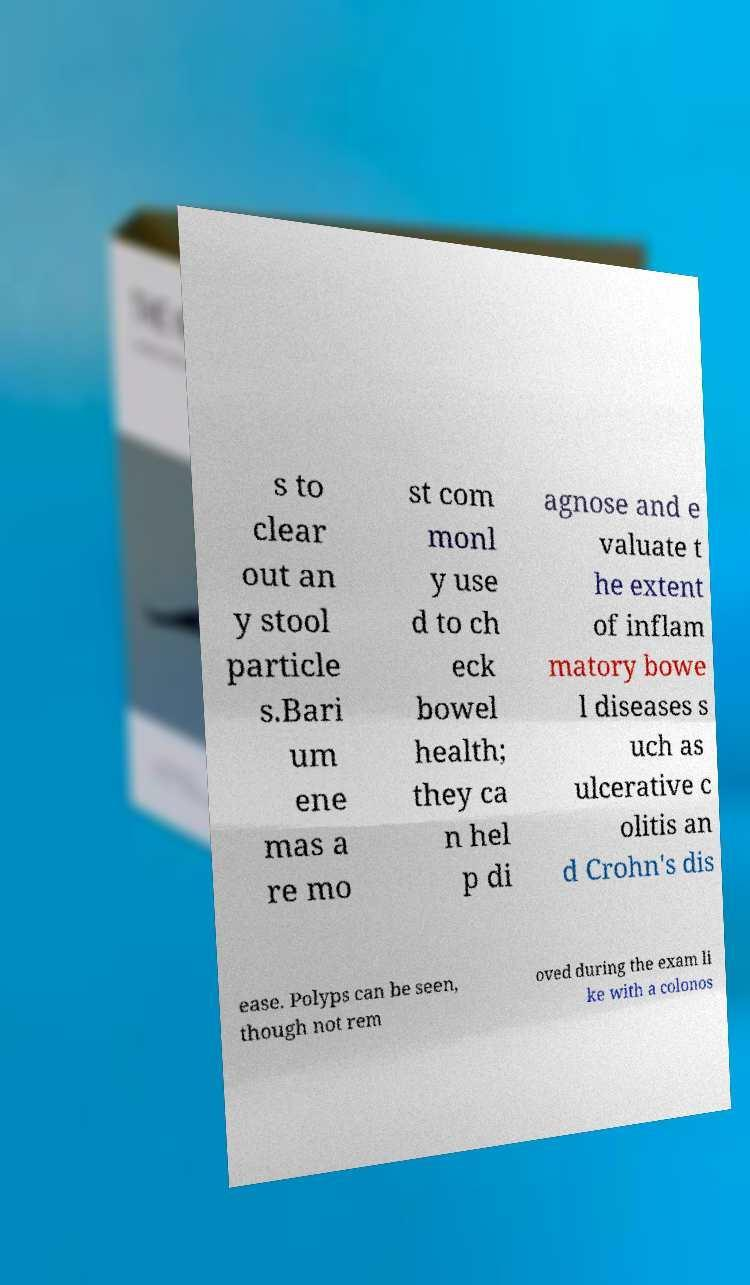Please identify and transcribe the text found in this image. s to clear out an y stool particle s.Bari um ene mas a re mo st com monl y use d to ch eck bowel health; they ca n hel p di agnose and e valuate t he extent of inflam matory bowe l diseases s uch as ulcerative c olitis an d Crohn's dis ease. Polyps can be seen, though not rem oved during the exam li ke with a colonos 